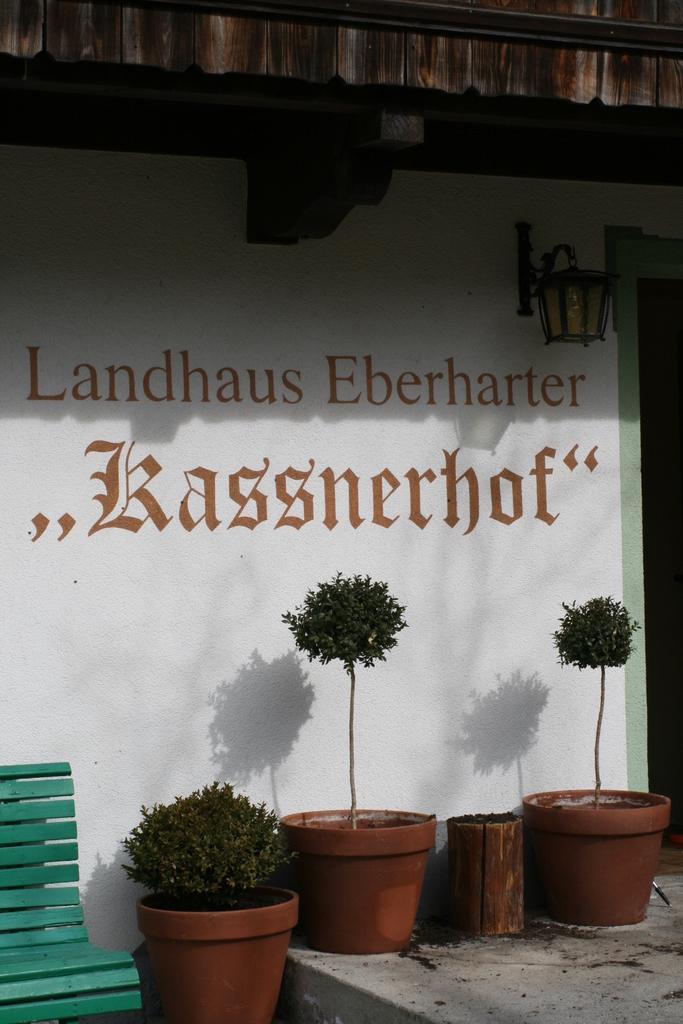How would you summarize this image in a sentence or two? Here I can see few house plants on the floor. On the left side, I can see a green color bench. At the back of these I can see a wall on which I can see some text. 